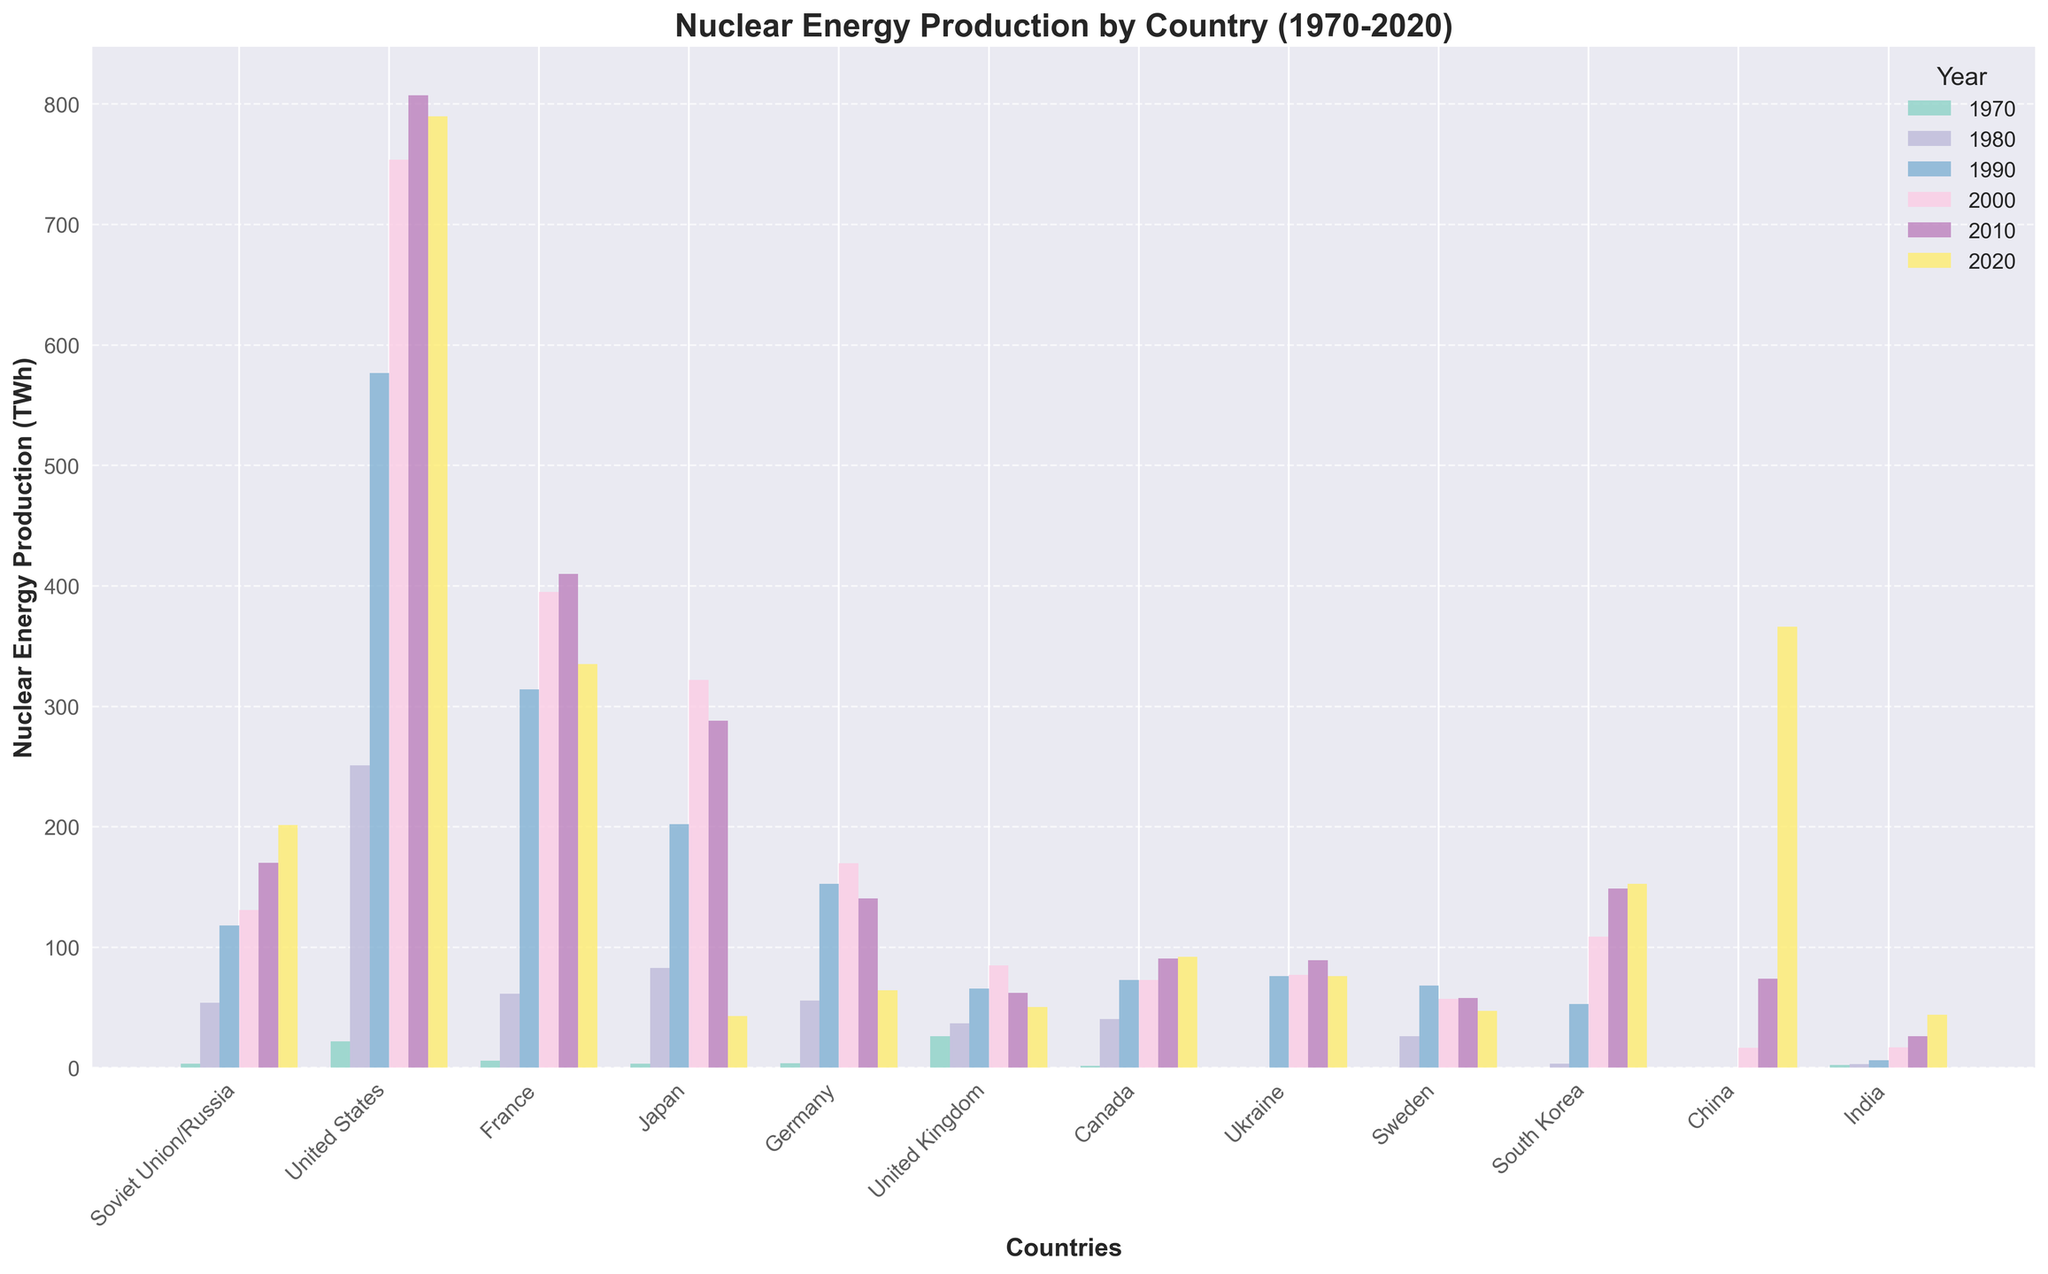Which country had the highest nuclear energy production in 2020? To find the answer, look at the height of the bars for each country in the year 2020. The highest bar corresponds to China, indicating that China had the highest nuclear energy production in 2020.
Answer: China Which country showed the greatest increase in nuclear energy production from 1970 to 2020? Calculate the difference between the 2020 and 1970 values for each country. The differences are: Soviet Union/Russia (198.1), United States (768.1), France (329.3), Japan (39.8), Germany (60.7), United Kingdom (24.2), Canada (90.7), Ukraine (76.2), Sweden (47.2), South Korea (152.6), China (366.2), India (41.5). The greatest increase is for the United States.
Answer: United States Which year had the lowest nuclear energy production for Japan? Observe the height of Japan's bars for each year. The shortest bar is for 2020, indicating that Japan had the lowest nuclear energy production that year.
Answer: 2020 Compare nuclear energy production in the UK and Canada in 2000. Which country produced more? Examine the height of the bars for the UK and Canada in the year 2000. Canada’s bar is slightly shorter than the UK's bar. Thus, the UK produced more nuclear energy in 2000 than Canada.
Answer: UK In which year did France have its peak nuclear energy production? Check the height of France's bars across all the years. The highest bar is for the year 2010. Thus, France had its peak nuclear energy production in 2010.
Answer: 2010 How did Germany's nuclear energy production change from 1990 to 2020? Compare the height of Germany's bars for 1990 and 2020. In 1990, the production is around 152.5 TWh, and in 2020, it is around 64.4 TWh. Thus, Germany's nuclear energy production decreased by 88.1 TWh from 1990 to 2020.
Answer: Decreased by 88.1 TWh Which country had a higher nuclear energy production in 1980: France or Soviet Union/Russia? Compare the height of bars for France and Soviet Union/Russia in 1980. France’s bar is slightly higher than Soviet Union/Russia’s bar. Hence, France had a higher nuclear energy production in 1980.
Answer: France How many countries had their highest nuclear energy production in 2020? Check each country’s bars to see if their steepest bar is in 2020. China and South Korea have their highest production in 2020. Thus, two countries had their peak in 2020.
Answer: 2 Calculate the average nuclear energy production for Canada over all the years provided. Add the nuclear energy production of Canada for each year and divide by the number of years. The sum of values is 1.5 + 40.5 + 72.9 + 72.8 + 90.7 + 92.2 = 370.6 TWh. There are six years, so the average is 370.6 / 6 = approximately 61.767 TWh.
Answer: 61.767 TWh 